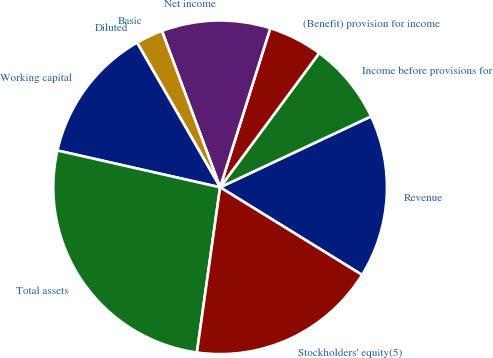Convert chart to OTSL. <chart><loc_0><loc_0><loc_500><loc_500><pie_chart><fcel>Revenue<fcel>Income before provisions for<fcel>(Benefit) provision for income<fcel>Net income<fcel>Basic<fcel>Diluted<fcel>Working capital<fcel>Total assets<fcel>Stockholders' equity(5)<nl><fcel>15.79%<fcel>7.89%<fcel>5.26%<fcel>10.53%<fcel>2.63%<fcel>0.0%<fcel>13.16%<fcel>26.32%<fcel>18.42%<nl></chart> 